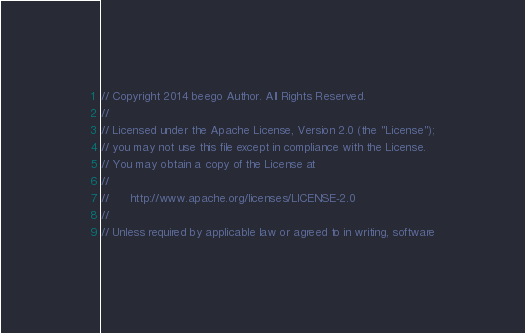<code> <loc_0><loc_0><loc_500><loc_500><_Go_>// Copyright 2014 beego Author. All Rights Reserved.
//
// Licensed under the Apache License, Version 2.0 (the "License");
// you may not use this file except in compliance with the License.
// You may obtain a copy of the License at
//
//      http://www.apache.org/licenses/LICENSE-2.0
//
// Unless required by applicable law or agreed to in writing, software</code> 